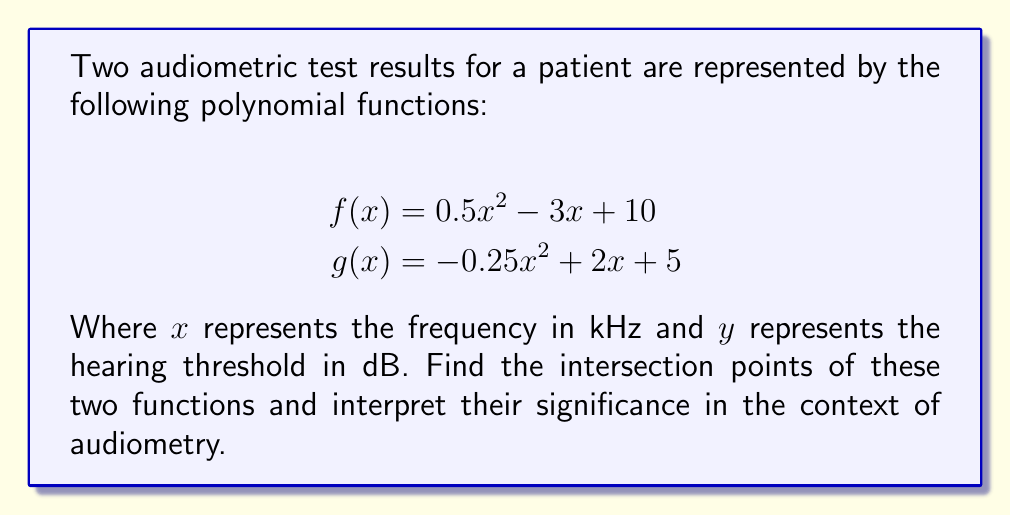Show me your answer to this math problem. To find the intersection points, we need to solve the equation $f(x) = g(x)$:

1) Set up the equation:
   $0.5x^2 - 3x + 10 = -0.25x^2 + 2x + 5$

2) Rearrange to standard form:
   $0.5x^2 + 0.25x^2 - 3x - 2x + 10 - 5 = 0$
   $0.75x^2 - 5x + 5 = 0$

3) Multiply all terms by 4 to simplify coefficients:
   $3x^2 - 20x + 20 = 0$

4) Use the quadratic formula: $x = \frac{-b \pm \sqrt{b^2 - 4ac}}{2a}$
   Where $a = 3$, $b = -20$, and $c = 20$

5) Substitute into the formula:
   $x = \frac{20 \pm \sqrt{400 - 240}}{6} = \frac{20 \pm \sqrt{160}}{6} = \frac{20 \pm 4\sqrt{10}}{6}$

6) Simplify:
   $x = \frac{10 \pm 2\sqrt{10}}{3}$

7) Calculate the y-coordinates by substituting either x-value into $f(x)$ or $g(x)$:
   For $x = \frac{10 + 2\sqrt{10}}{3}$:
   $y = 0.5(\frac{10 + 2\sqrt{10}}{3})^2 - 3(\frac{10 + 2\sqrt{10}}{3}) + 10 \approx 15.77$ dB

   For $x = \frac{10 - 2\sqrt{10}}{3}$:
   $y = 0.5(\frac{10 - 2\sqrt{10}}{3})^2 - 3(\frac{10 - 2\sqrt{10}}{3}) + 10 \approx 8.90$ dB

Interpretation: The intersection points represent frequencies where the hearing thresholds from both tests are equal. At approximately 5.44 kHz, both tests show a hearing threshold of about 15.77 dB. At approximately 1.22 kHz, both tests indicate a hearing threshold of about 8.90 dB. These points are crucial for comparing the consistency of test results and identifying potential discrepancies in different frequency ranges.
Answer: The intersection points are:
$(\frac{10 + 2\sqrt{10}}{3}, 15.77)$ or approximately $(5.44, 15.77)$
$(\frac{10 - 2\sqrt{10}}{3}, 8.90)$ or approximately $(1.22, 8.90)$
where the x-coordinate represents frequency in kHz and the y-coordinate represents hearing threshold in dB. 